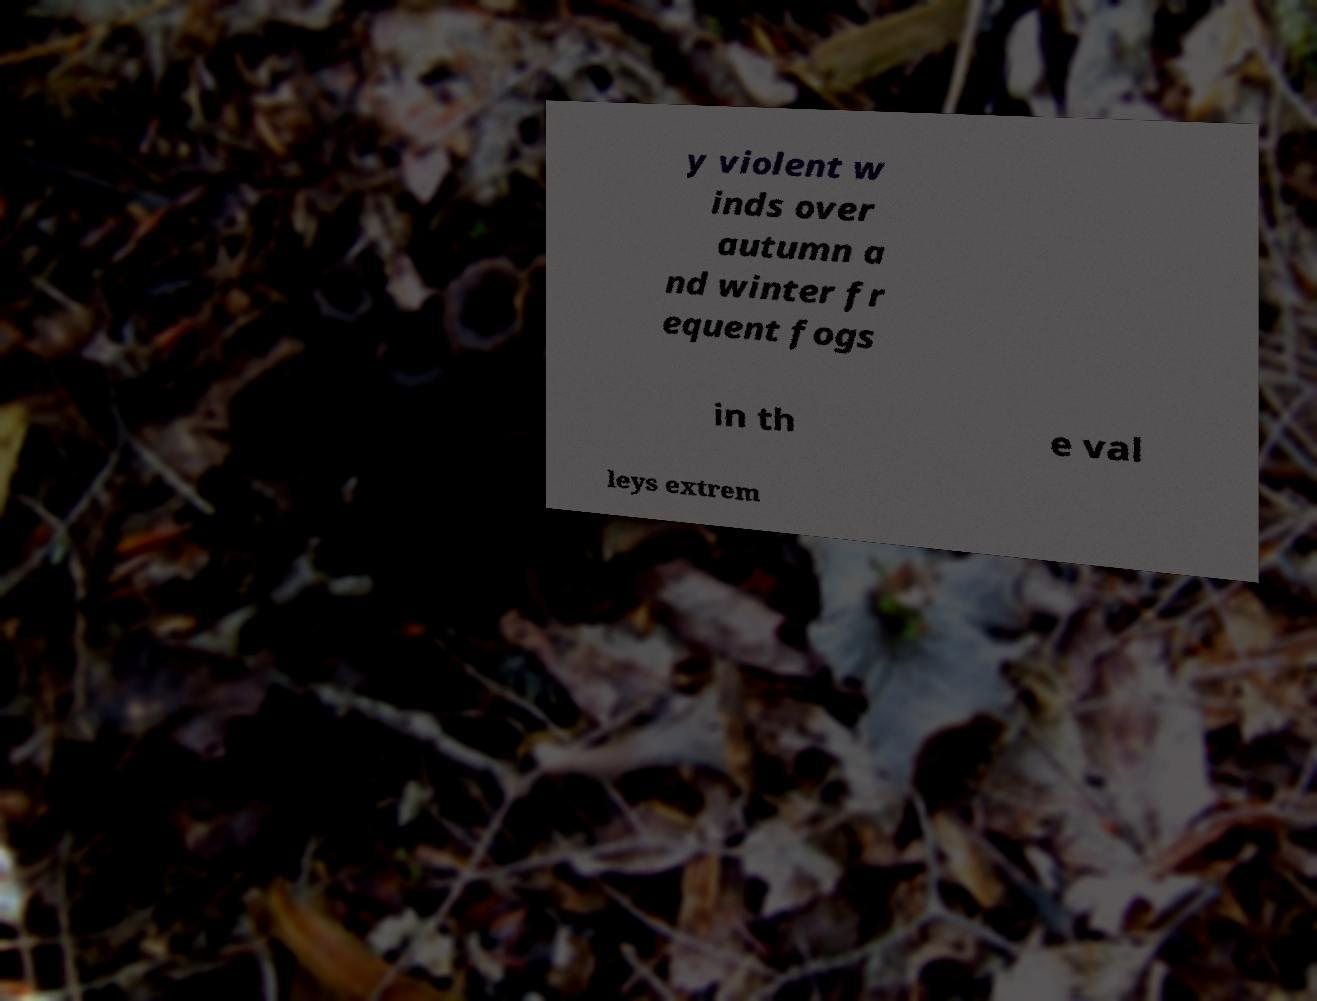Could you assist in decoding the text presented in this image and type it out clearly? y violent w inds over autumn a nd winter fr equent fogs in th e val leys extrem 